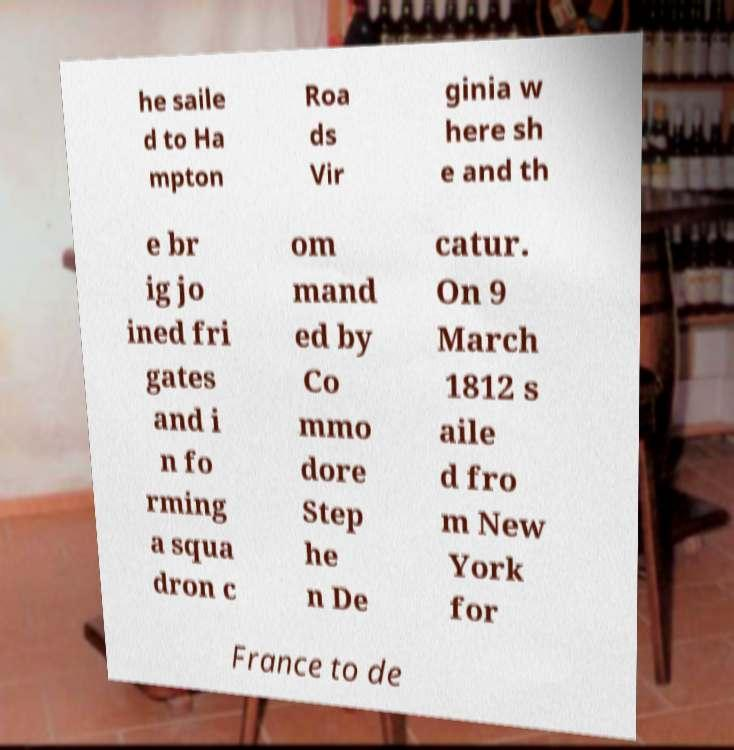Please read and relay the text visible in this image. What does it say? he saile d to Ha mpton Roa ds Vir ginia w here sh e and th e br ig jo ined fri gates and i n fo rming a squa dron c om mand ed by Co mmo dore Step he n De catur. On 9 March 1812 s aile d fro m New York for France to de 